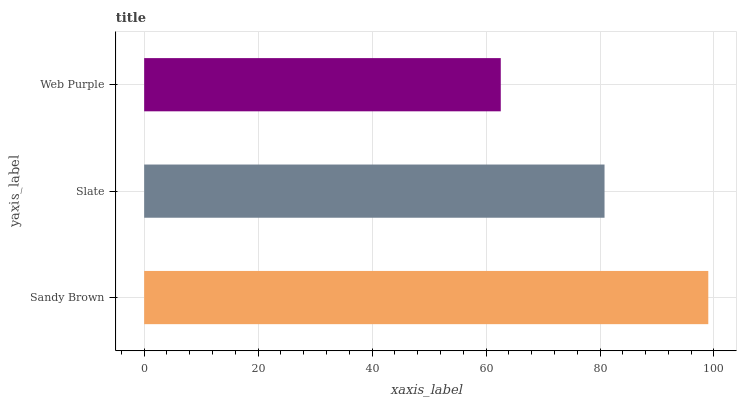Is Web Purple the minimum?
Answer yes or no. Yes. Is Sandy Brown the maximum?
Answer yes or no. Yes. Is Slate the minimum?
Answer yes or no. No. Is Slate the maximum?
Answer yes or no. No. Is Sandy Brown greater than Slate?
Answer yes or no. Yes. Is Slate less than Sandy Brown?
Answer yes or no. Yes. Is Slate greater than Sandy Brown?
Answer yes or no. No. Is Sandy Brown less than Slate?
Answer yes or no. No. Is Slate the high median?
Answer yes or no. Yes. Is Slate the low median?
Answer yes or no. Yes. Is Sandy Brown the high median?
Answer yes or no. No. Is Web Purple the low median?
Answer yes or no. No. 